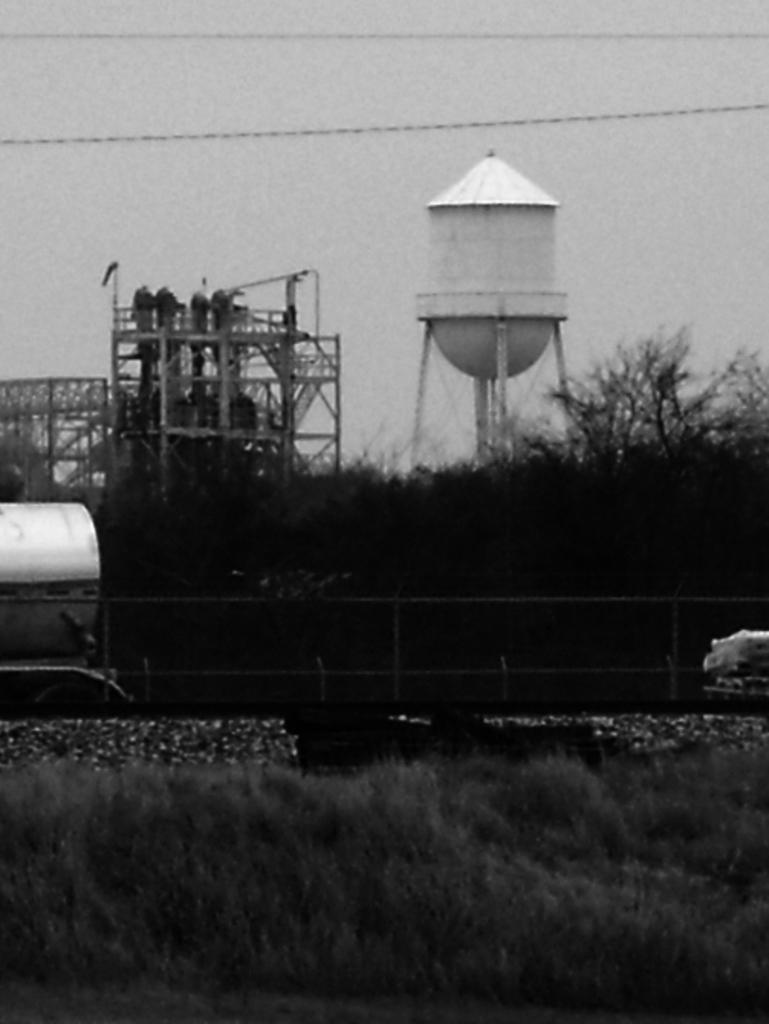In one or two sentences, can you explain what this image depicts? This is a black and white image. At the bottom of the image there is grass. Behind the grass there is fencing. Behind the fencing there is a tanker. And also there are trees. Behind the trees there is a water tank. 